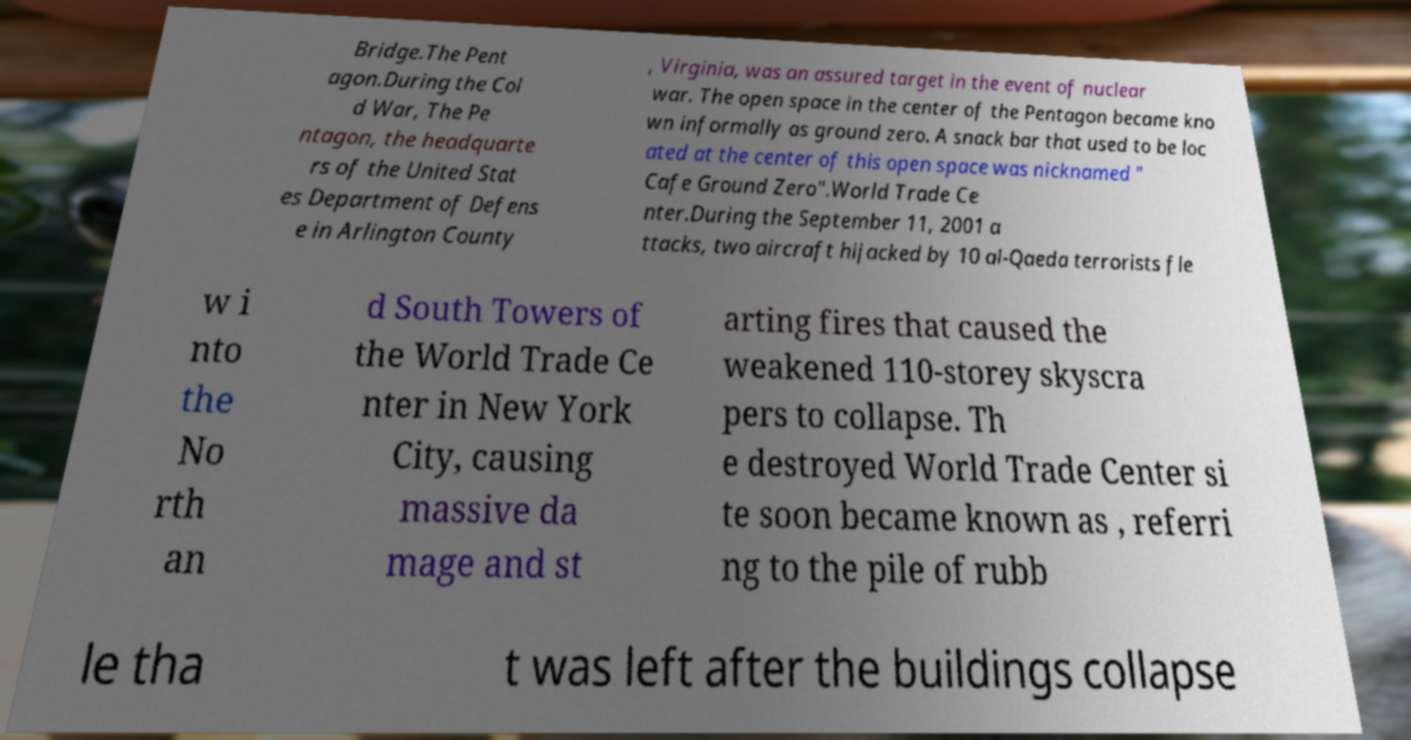Can you accurately transcribe the text from the provided image for me? Bridge.The Pent agon.During the Col d War, The Pe ntagon, the headquarte rs of the United Stat es Department of Defens e in Arlington County , Virginia, was an assured target in the event of nuclear war. The open space in the center of the Pentagon became kno wn informally as ground zero. A snack bar that used to be loc ated at the center of this open space was nicknamed " Cafe Ground Zero".World Trade Ce nter.During the September 11, 2001 a ttacks, two aircraft hijacked by 10 al-Qaeda terrorists fle w i nto the No rth an d South Towers of the World Trade Ce nter in New York City, causing massive da mage and st arting fires that caused the weakened 110-storey skyscra pers to collapse. Th e destroyed World Trade Center si te soon became known as , referri ng to the pile of rubb le tha t was left after the buildings collapse 